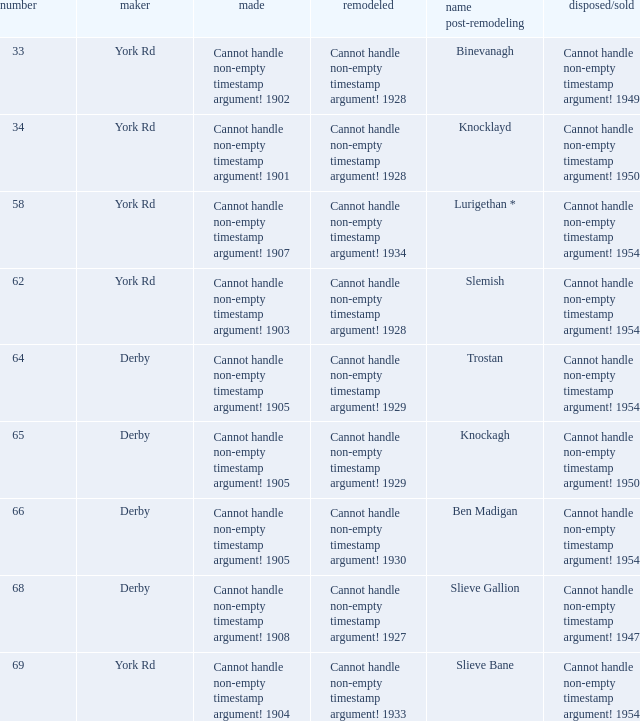Which Scrapped/Sold has a Builder of derby, and a Name as rebuilt of ben madigan? Cannot handle non-empty timestamp argument! 1954. 